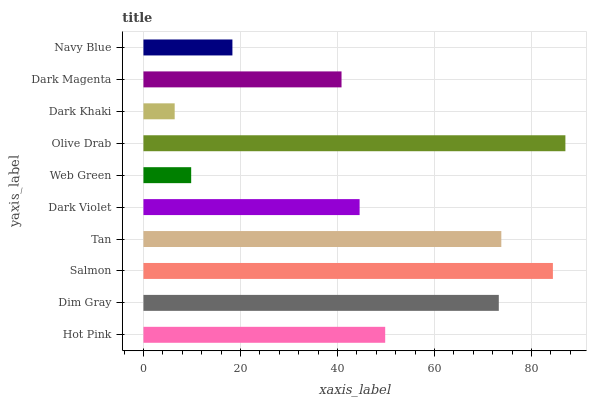Is Dark Khaki the minimum?
Answer yes or no. Yes. Is Olive Drab the maximum?
Answer yes or no. Yes. Is Dim Gray the minimum?
Answer yes or no. No. Is Dim Gray the maximum?
Answer yes or no. No. Is Dim Gray greater than Hot Pink?
Answer yes or no. Yes. Is Hot Pink less than Dim Gray?
Answer yes or no. Yes. Is Hot Pink greater than Dim Gray?
Answer yes or no. No. Is Dim Gray less than Hot Pink?
Answer yes or no. No. Is Hot Pink the high median?
Answer yes or no. Yes. Is Dark Violet the low median?
Answer yes or no. Yes. Is Olive Drab the high median?
Answer yes or no. No. Is Dark Khaki the low median?
Answer yes or no. No. 